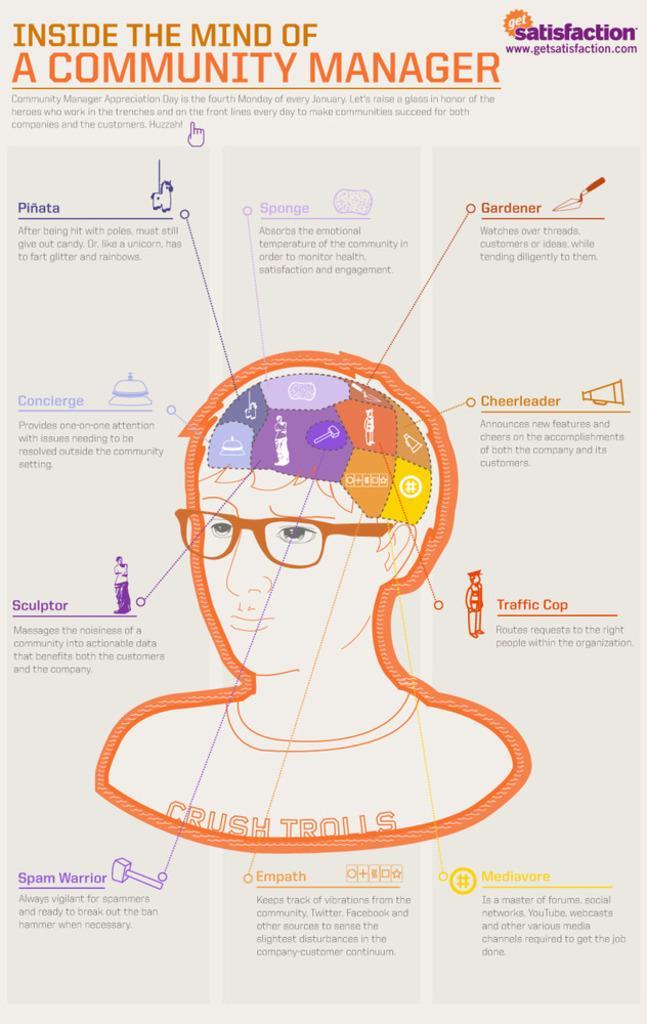Please provide a concise description of this image. This is the paper where the headline is written inside the mind of a community manager and we can see a person wearing spectacle and shirt where it is written crush trolls, the part of brain is explained. 